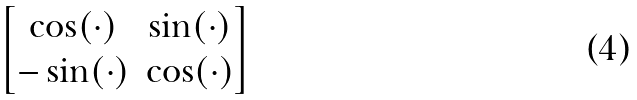Convert formula to latex. <formula><loc_0><loc_0><loc_500><loc_500>\begin{bmatrix} \cos ( \cdot ) & \sin ( \cdot ) \\ - \sin ( \cdot ) & \cos ( \cdot ) \end{bmatrix}</formula> 